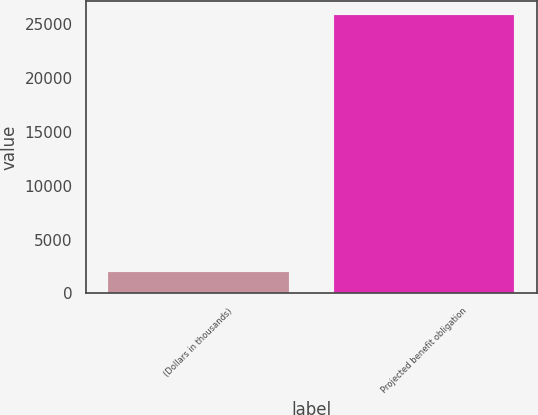Convert chart to OTSL. <chart><loc_0><loc_0><loc_500><loc_500><bar_chart><fcel>(Dollars in thousands)<fcel>Projected benefit obligation<nl><fcel>2009<fcel>25831<nl></chart> 